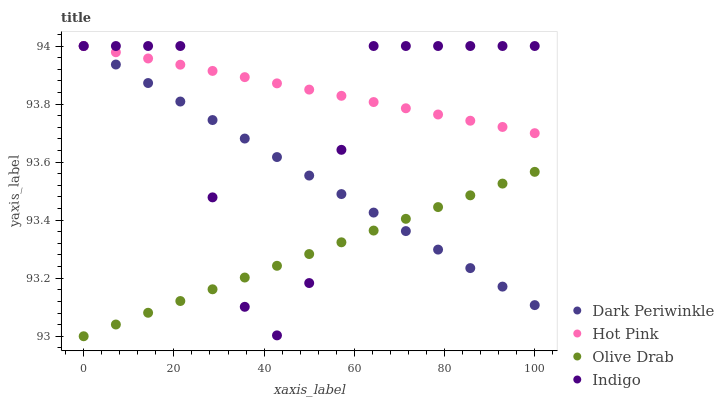Does Olive Drab have the minimum area under the curve?
Answer yes or no. Yes. Does Hot Pink have the maximum area under the curve?
Answer yes or no. Yes. Does Indigo have the minimum area under the curve?
Answer yes or no. No. Does Indigo have the maximum area under the curve?
Answer yes or no. No. Is Dark Periwinkle the smoothest?
Answer yes or no. Yes. Is Indigo the roughest?
Answer yes or no. Yes. Is Indigo the smoothest?
Answer yes or no. No. Is Dark Periwinkle the roughest?
Answer yes or no. No. Does Olive Drab have the lowest value?
Answer yes or no. Yes. Does Indigo have the lowest value?
Answer yes or no. No. Does Dark Periwinkle have the highest value?
Answer yes or no. Yes. Does Olive Drab have the highest value?
Answer yes or no. No. Is Olive Drab less than Hot Pink?
Answer yes or no. Yes. Is Hot Pink greater than Olive Drab?
Answer yes or no. Yes. Does Indigo intersect Dark Periwinkle?
Answer yes or no. Yes. Is Indigo less than Dark Periwinkle?
Answer yes or no. No. Is Indigo greater than Dark Periwinkle?
Answer yes or no. No. Does Olive Drab intersect Hot Pink?
Answer yes or no. No. 